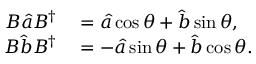<formula> <loc_0><loc_0><loc_500><loc_500>\begin{array} { r l } { B \hat { a } B ^ { \dagger } } & = \hat { a } \cos \theta + \hat { b } \sin \theta , } \\ { B \hat { b } B ^ { \dagger } } & = - \hat { a } \sin \theta + \hat { b } \cos \theta . } \end{array}</formula> 